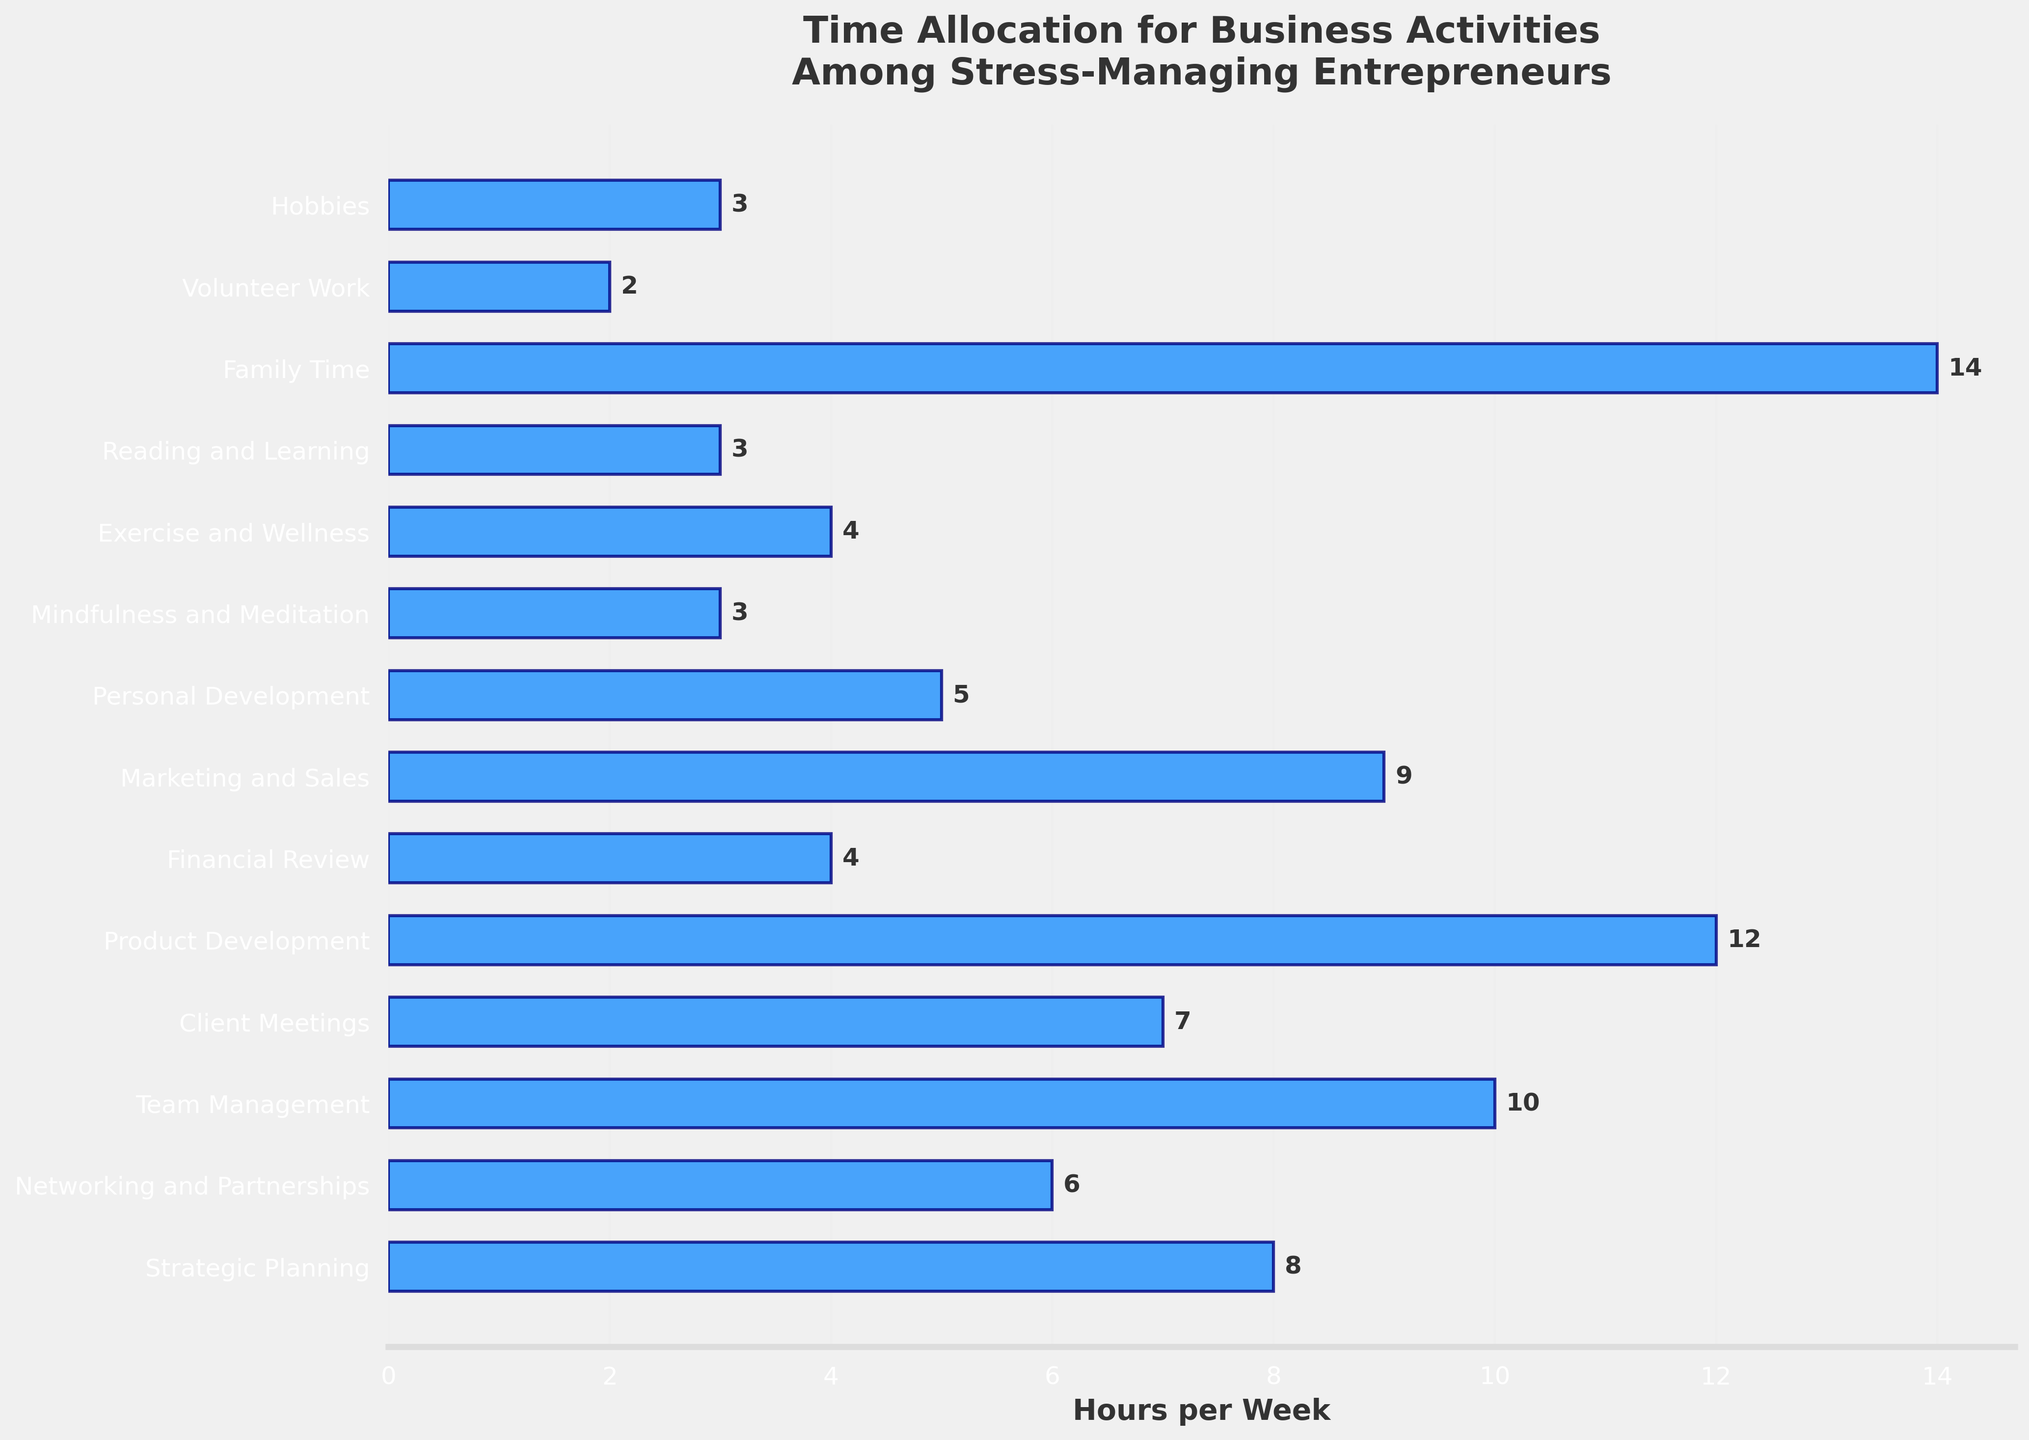Which activity takes up the most time per week? The bar representing "Family Time" is the longest and records 14 hours per week.
Answer: Family Time Which activity has the least number of hours allocated per week? The bar for "Volunteer Work" is the shortest, showing 2 hours per week.
Answer: Volunteer Work How many hours in total are allocated to reading and learning, hobbies, and mindfulness and meditation combined? Add the hours from "Reading and Learning" (3 hours), "Hobbies" (3 hours), and "Mindfulness and Meditation" (3 hours), giving 3 + 3 + 3 = 9 hours.
Answer: 9 hours Which activity has more hours allocated: client meetings or marketing and sales? The bar for "Marketing and Sales" (9 hours) is longer than the bar for "Client Meetings" (7 hours) indicating more hours.
Answer: Marketing and Sales Is the number of hours allocated to exercise and wellness greater than the number of hours allocated to financial review? The bar for "Exercise and Wellness" shows 4 hours, and the bar for "Financial Review" also shows 4 hours. Therefore, they have equal hours allocated.
Answer: No, they are equal What is the difference in hours allocated between team management and personal development? The bar for "Team Management" records 10 hours and for "Personal Development" is 5 hours. The difference is 10 - 5 = 5 hours.
Answer: 5 hours On average, how many hours are spent on product development, marketing and sales, and strategic planning? The hours are 12 (Product Development), 9 (Marketing and Sales), and 8 (Strategic Planning). The average is (12 + 9 + 8) / 3 = 29 / 3 ≈ 9.67 hours.
Answer: 9.67 hours Which non-business activity takes up more hours per week: exercise and wellness or family time? The bar for "Family Time" indicates 14 hours, which is longer than the bar for "Exercise and Wellness" showing 4 hours. Therefore, more hours are spent on family time.
Answer: Family Time How many hours total are allocated to professional development activities (Strategic Planning, Networking and Partnerships, and Personal Development)? Sum the hours for "Strategic Planning" (8 hours), "Networking and Partnerships" (6 hours), and "Personal Development" (5 hours). This gives 8 + 6 + 5 = 19 hours.
Answer: 19 hours 